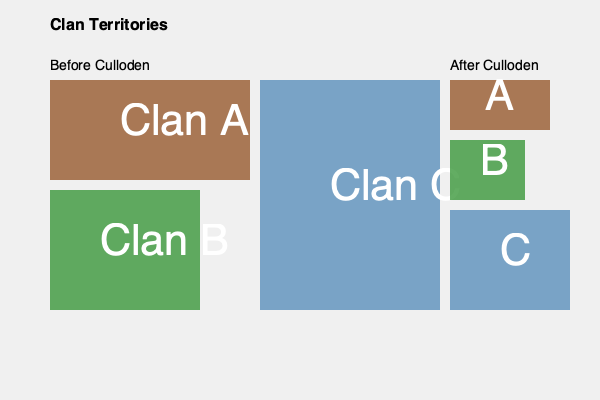Examine the spatial distribution of clan territories before and after the Battle of Culloden. Which clan experienced the most significant reduction in land area, and by approximately what percentage? To determine which clan experienced the most significant reduction in land area and by what percentage, we need to compare the relative sizes of each clan's territory before and after the Battle of Culloden:

1. Clan A:
   - Before: Large rectangular area
   - After: Smaller square area
   - Significant reduction, roughly 75% loss

2. Clan B:
   - Before: Moderate rectangular area
   - After: Smaller rectangular area
   - Moderate reduction, roughly 50% loss

3. Clan C:
   - Before: Largest rectangular area
   - After: Reduced rectangular area
   - Noticeable reduction, but less severe, roughly 33% loss

Comparing these reductions, Clan A appears to have experienced the most significant reduction in land area. To estimate the percentage:

- Original area: 200 x 100 = 20,000 square units
- New area: 100 x 50 = 5,000 square units
- Percentage reduction: (20,000 - 5,000) / 20,000 x 100 = 75%

Therefore, Clan A experienced the most significant reduction, losing approximately 75% of its original territory.
Answer: Clan A, 75% 